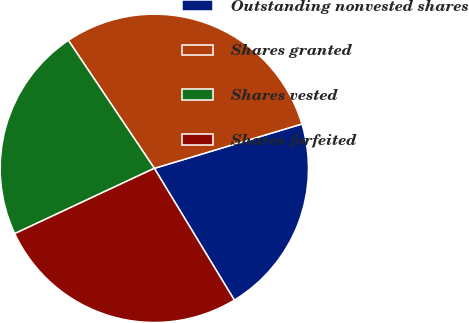Convert chart to OTSL. <chart><loc_0><loc_0><loc_500><loc_500><pie_chart><fcel>Outstanding nonvested shares<fcel>Shares granted<fcel>Shares vested<fcel>Shares forfeited<nl><fcel>20.96%<fcel>29.77%<fcel>22.55%<fcel>26.72%<nl></chart> 